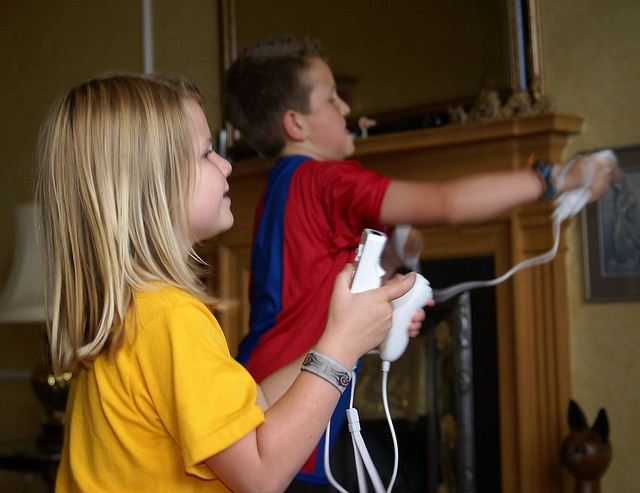Describe the objects in this image and their specific colors. I can see people in black, orange, tan, and gray tones, people in black, brown, gray, and maroon tones, remote in black, lavender, darkgray, and gray tones, remote in black, white, darkgray, and gray tones, and remote in black, darkgray, and gray tones in this image. 